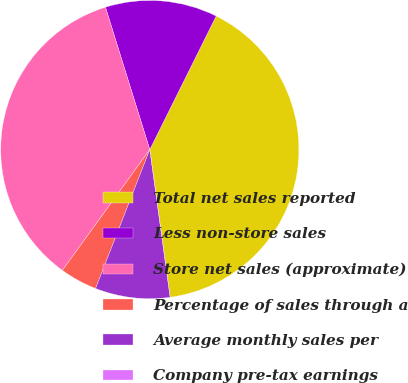Convert chart to OTSL. <chart><loc_0><loc_0><loc_500><loc_500><pie_chart><fcel>Total net sales reported<fcel>Less non-store sales<fcel>Store net sales (approximate)<fcel>Percentage of sales through a<fcel>Average monthly sales per<fcel>Company pre-tax earnings<nl><fcel>40.48%<fcel>12.15%<fcel>35.22%<fcel>4.05%<fcel>8.1%<fcel>0.0%<nl></chart> 